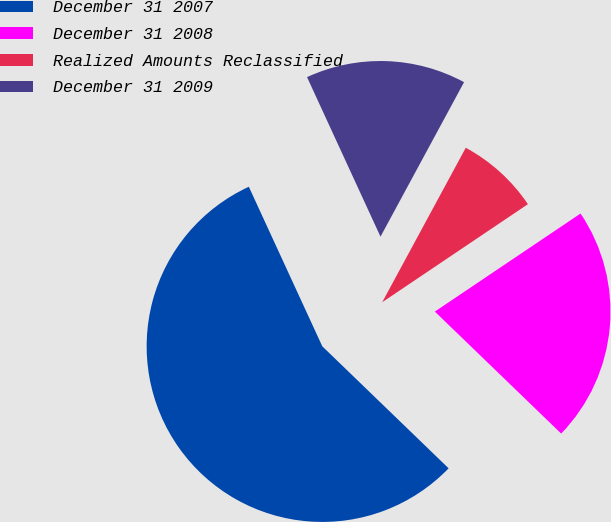Convert chart. <chart><loc_0><loc_0><loc_500><loc_500><pie_chart><fcel>December 31 2007<fcel>December 31 2008<fcel>Realized Amounts Reclassified<fcel>December 31 2009<nl><fcel>55.91%<fcel>21.65%<fcel>7.68%<fcel>14.76%<nl></chart> 